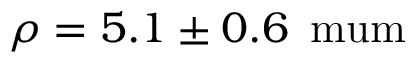Convert formula to latex. <formula><loc_0><loc_0><loc_500><loc_500>\rho = 5 . 1 \pm 0 . 6 \, { \ m u m }</formula> 